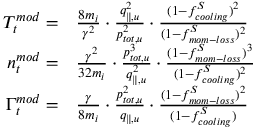Convert formula to latex. <formula><loc_0><loc_0><loc_500><loc_500>\begin{array} { r l } { T _ { t } ^ { m o d } = } & \frac { 8 m _ { i } } { \gamma ^ { 2 } } \cdot \frac { q _ { \| , u } ^ { 2 } } { p _ { t o t , u } ^ { 2 } } \cdot \frac { ( 1 - f _ { c o o l i n g } ^ { S } ) ^ { 2 } } { ( 1 - f _ { m o m - l o s s } ^ { S } ) ^ { 2 } } } \\ { n _ { t } ^ { m o d } = } & \frac { \gamma ^ { 2 } } { 3 2 m _ { i } } \cdot \frac { p _ { t o t , u } ^ { 3 } } { q _ { \| , u } ^ { 2 } } \cdot \frac { ( 1 - f _ { m o m - l o s s } ^ { S } ) ^ { 3 } } { ( 1 - f _ { c o o l i n g } ^ { S } ) ^ { 2 } } } \\ { \Gamma _ { t } ^ { m o d } = } & \frac { \gamma } { 8 m _ { i } } \cdot \frac { p _ { t o t , u } ^ { 2 } } { q _ { \| , u } } \cdot \frac { ( 1 - f _ { m o m - l o s s } ^ { S } ) ^ { 2 } } { ( 1 - f _ { c o o l i n g } ^ { S } ) } } \end{array}</formula> 